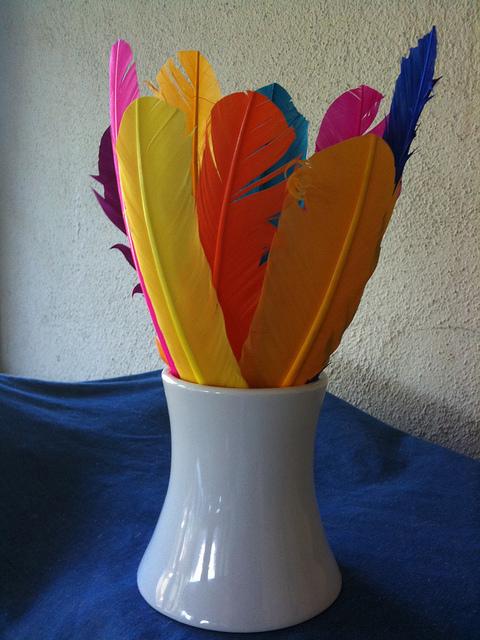Does this vase look heavy?
Answer briefly. No. What colors are the feathers?
Write a very short answer. Multi-colored. What color is the vase?
Keep it brief. White. What are these used for?
Concise answer only. Decoration. How many feathers are there?
Concise answer only. 9. 